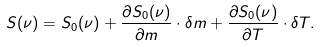Convert formula to latex. <formula><loc_0><loc_0><loc_500><loc_500>S ( \nu ) = S _ { 0 } ( \nu ) + \frac { \partial S _ { 0 } ( \nu ) } { \partial m } \cdot \delta m + \frac { \partial S _ { 0 } ( \nu ) } { \partial T } \cdot \delta T .</formula> 